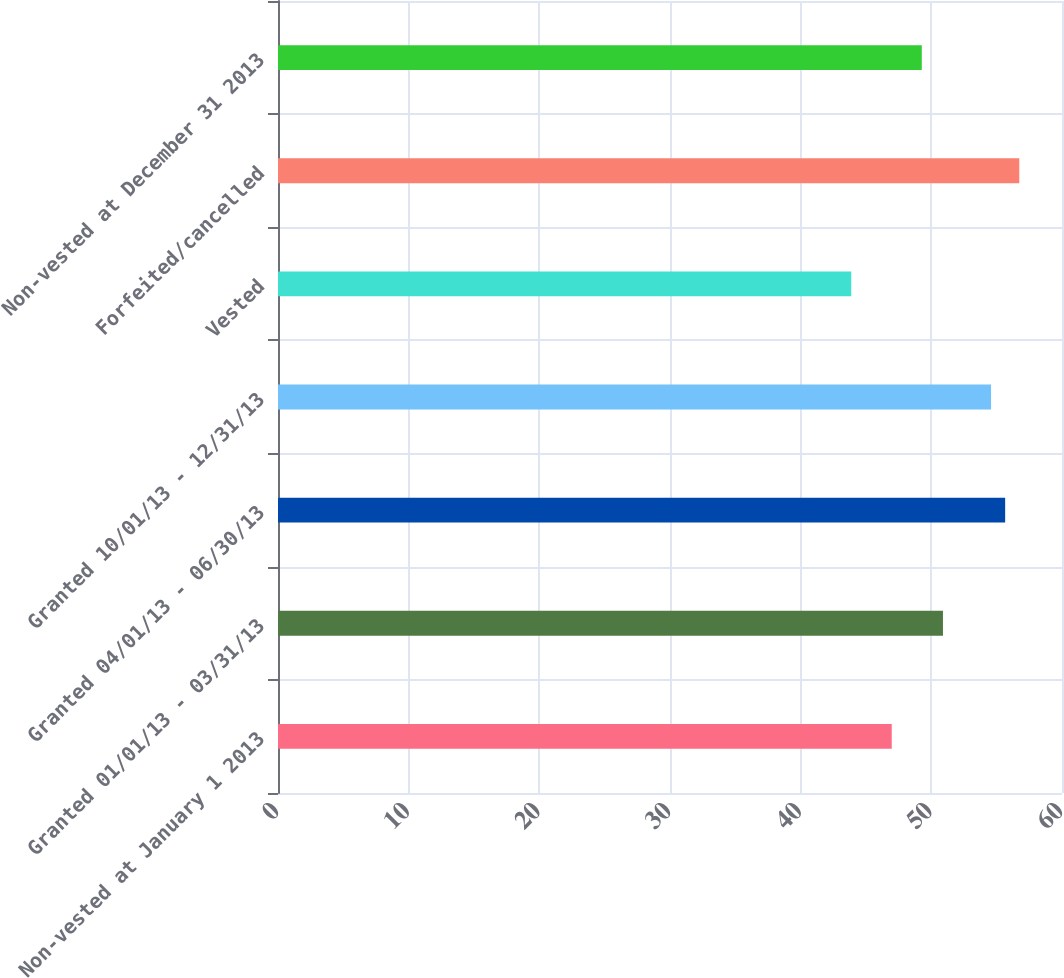<chart> <loc_0><loc_0><loc_500><loc_500><bar_chart><fcel>Non-vested at January 1 2013<fcel>Granted 01/01/13 - 03/31/13<fcel>Granted 04/01/13 - 06/30/13<fcel>Granted 10/01/13 - 12/31/13<fcel>Vested<fcel>Forfeited/cancelled<fcel>Non-vested at December 31 2013<nl><fcel>46.97<fcel>50.89<fcel>55.65<fcel>54.57<fcel>43.87<fcel>56.73<fcel>49.27<nl></chart> 